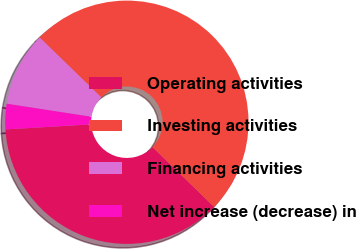Convert chart. <chart><loc_0><loc_0><loc_500><loc_500><pie_chart><fcel>Operating activities<fcel>Investing activities<fcel>Financing activities<fcel>Net increase (decrease) in<nl><fcel>36.8%<fcel>49.99%<fcel>9.83%<fcel>3.38%<nl></chart> 